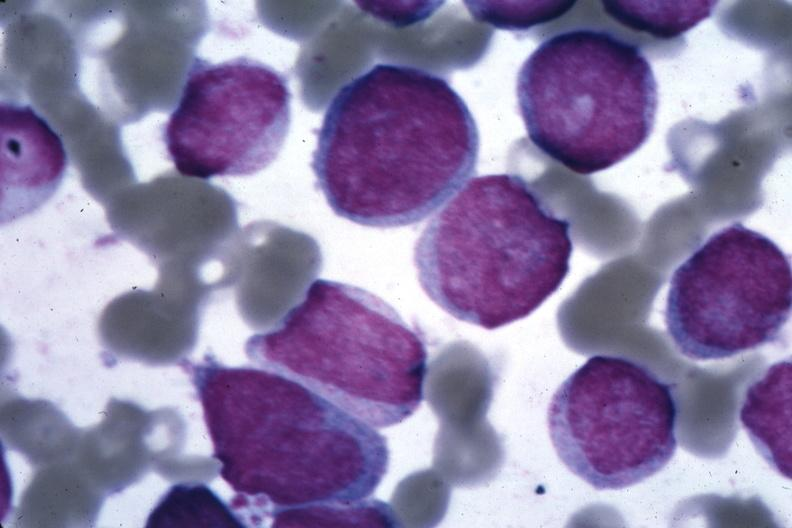what does this image show?
Answer the question using a single word or phrase. Oil wrights cells easily diagnosed 